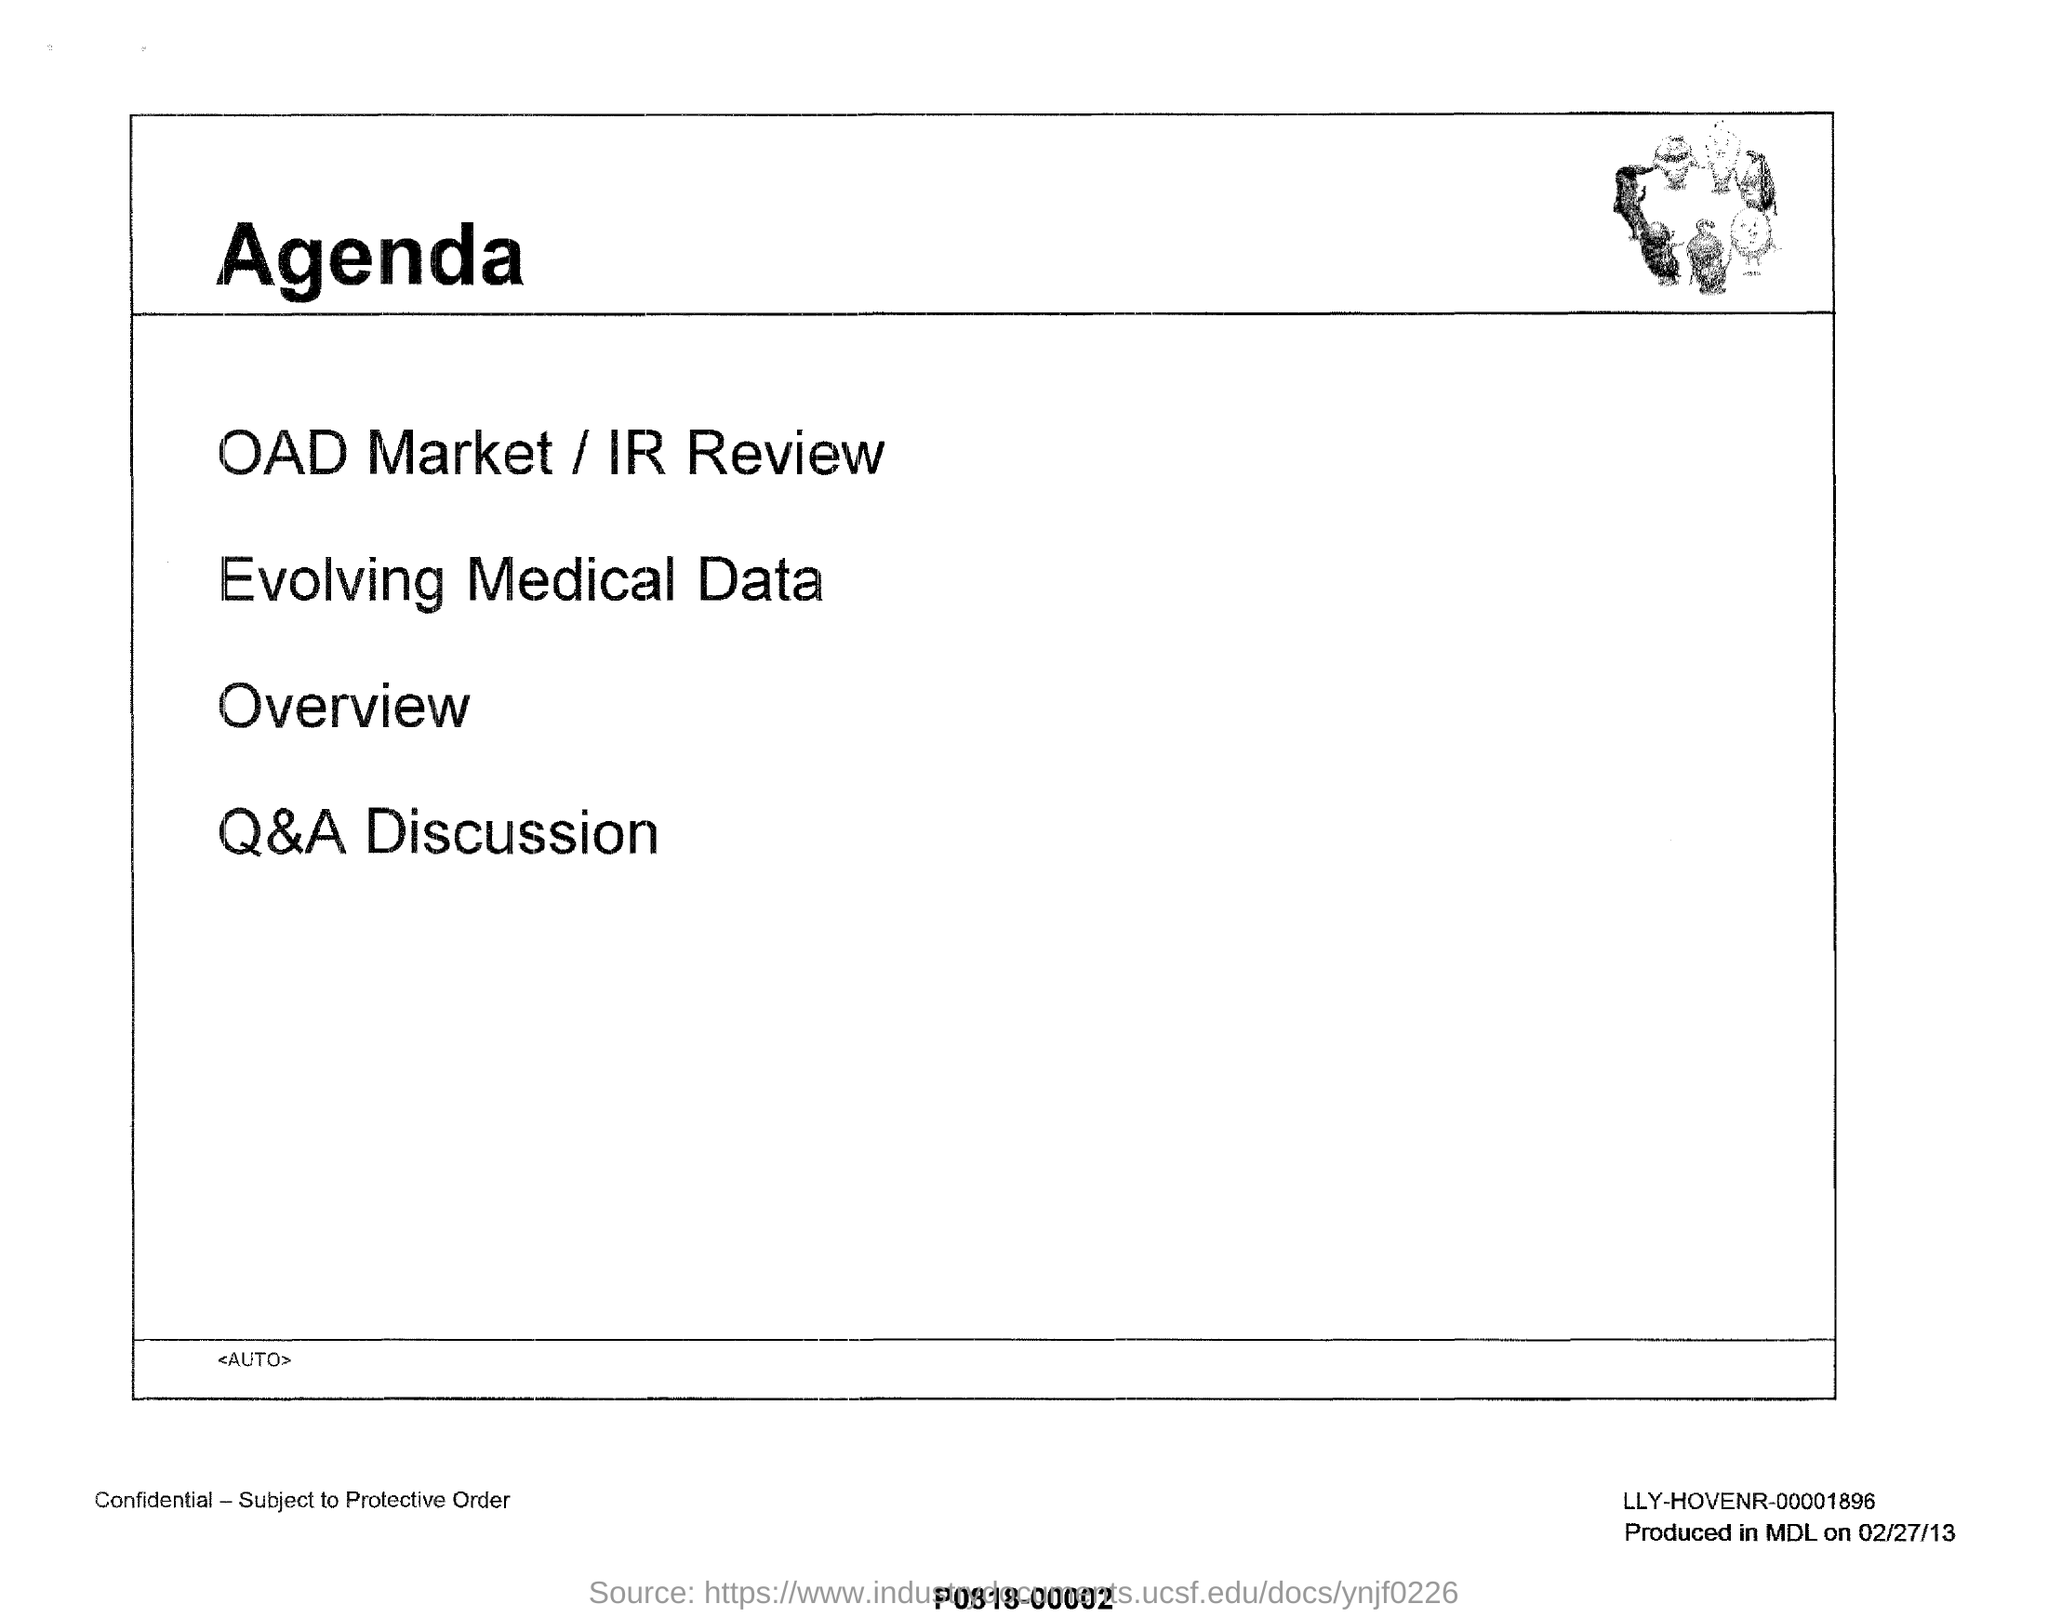Give some essential details in this illustration. The OAD Market / IR Review is the first item on the agenda. The last item on the agenda is Q&A Discussion. This document is titled 'Agenda.' 